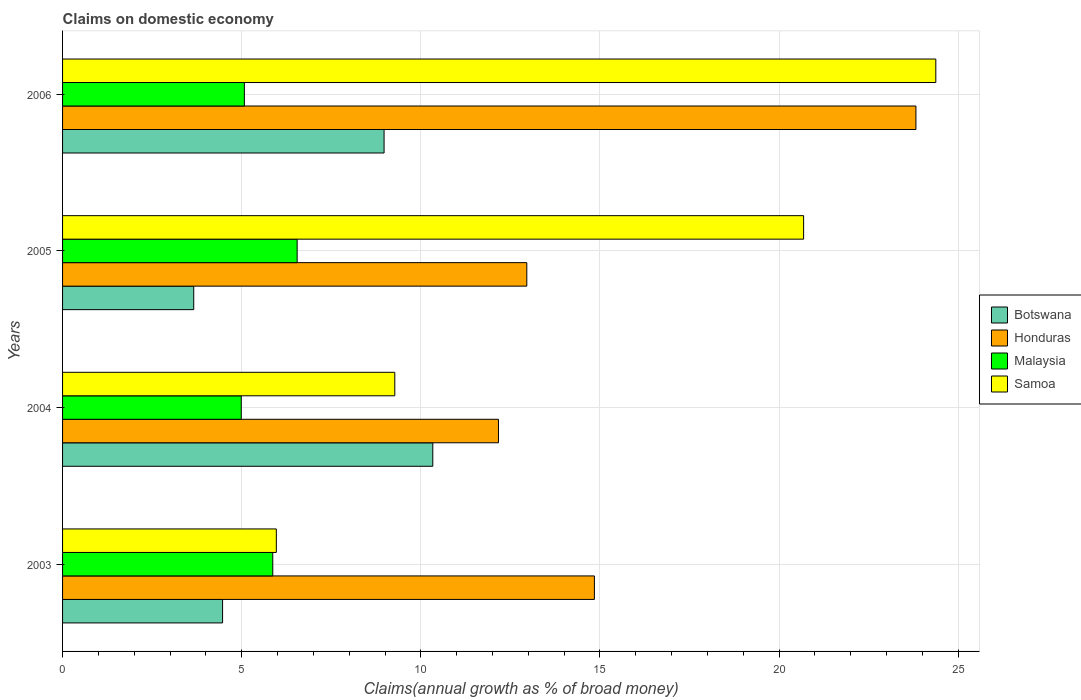How many different coloured bars are there?
Your answer should be compact. 4. How many groups of bars are there?
Keep it short and to the point. 4. Are the number of bars on each tick of the Y-axis equal?
Offer a very short reply. Yes. How many bars are there on the 3rd tick from the top?
Offer a terse response. 4. What is the label of the 2nd group of bars from the top?
Your answer should be very brief. 2005. What is the percentage of broad money claimed on domestic economy in Samoa in 2005?
Ensure brevity in your answer.  20.68. Across all years, what is the maximum percentage of broad money claimed on domestic economy in Botswana?
Provide a succinct answer. 10.33. Across all years, what is the minimum percentage of broad money claimed on domestic economy in Malaysia?
Your answer should be compact. 4.99. In which year was the percentage of broad money claimed on domestic economy in Honduras maximum?
Offer a very short reply. 2006. What is the total percentage of broad money claimed on domestic economy in Botswana in the graph?
Provide a short and direct response. 27.44. What is the difference between the percentage of broad money claimed on domestic economy in Samoa in 2004 and that in 2006?
Offer a very short reply. -15.1. What is the difference between the percentage of broad money claimed on domestic economy in Honduras in 2006 and the percentage of broad money claimed on domestic economy in Samoa in 2003?
Ensure brevity in your answer.  17.85. What is the average percentage of broad money claimed on domestic economy in Samoa per year?
Your answer should be very brief. 15.08. In the year 2005, what is the difference between the percentage of broad money claimed on domestic economy in Botswana and percentage of broad money claimed on domestic economy in Samoa?
Your response must be concise. -17.02. What is the ratio of the percentage of broad money claimed on domestic economy in Botswana in 2004 to that in 2006?
Your answer should be very brief. 1.15. What is the difference between the highest and the second highest percentage of broad money claimed on domestic economy in Botswana?
Make the answer very short. 1.36. What is the difference between the highest and the lowest percentage of broad money claimed on domestic economy in Samoa?
Your response must be concise. 18.41. What does the 1st bar from the top in 2004 represents?
Your response must be concise. Samoa. What does the 2nd bar from the bottom in 2006 represents?
Keep it short and to the point. Honduras. How many years are there in the graph?
Keep it short and to the point. 4. Are the values on the major ticks of X-axis written in scientific E-notation?
Offer a very short reply. No. Does the graph contain any zero values?
Your response must be concise. No. Where does the legend appear in the graph?
Make the answer very short. Center right. How many legend labels are there?
Give a very brief answer. 4. What is the title of the graph?
Your answer should be very brief. Claims on domestic economy. What is the label or title of the X-axis?
Keep it short and to the point. Claims(annual growth as % of broad money). What is the Claims(annual growth as % of broad money) in Botswana in 2003?
Make the answer very short. 4.47. What is the Claims(annual growth as % of broad money) in Honduras in 2003?
Your answer should be compact. 14.84. What is the Claims(annual growth as % of broad money) in Malaysia in 2003?
Your answer should be very brief. 5.87. What is the Claims(annual growth as % of broad money) in Samoa in 2003?
Your answer should be compact. 5.97. What is the Claims(annual growth as % of broad money) of Botswana in 2004?
Offer a very short reply. 10.33. What is the Claims(annual growth as % of broad money) of Honduras in 2004?
Offer a very short reply. 12.17. What is the Claims(annual growth as % of broad money) in Malaysia in 2004?
Provide a succinct answer. 4.99. What is the Claims(annual growth as % of broad money) in Samoa in 2004?
Your answer should be compact. 9.27. What is the Claims(annual growth as % of broad money) of Botswana in 2005?
Give a very brief answer. 3.66. What is the Claims(annual growth as % of broad money) in Honduras in 2005?
Provide a succinct answer. 12.96. What is the Claims(annual growth as % of broad money) of Malaysia in 2005?
Your response must be concise. 6.55. What is the Claims(annual growth as % of broad money) in Samoa in 2005?
Provide a succinct answer. 20.68. What is the Claims(annual growth as % of broad money) in Botswana in 2006?
Keep it short and to the point. 8.97. What is the Claims(annual growth as % of broad money) in Honduras in 2006?
Your answer should be very brief. 23.82. What is the Claims(annual growth as % of broad money) of Malaysia in 2006?
Offer a terse response. 5.07. What is the Claims(annual growth as % of broad money) in Samoa in 2006?
Offer a very short reply. 24.37. Across all years, what is the maximum Claims(annual growth as % of broad money) in Botswana?
Keep it short and to the point. 10.33. Across all years, what is the maximum Claims(annual growth as % of broad money) in Honduras?
Provide a short and direct response. 23.82. Across all years, what is the maximum Claims(annual growth as % of broad money) in Malaysia?
Your answer should be very brief. 6.55. Across all years, what is the maximum Claims(annual growth as % of broad money) of Samoa?
Provide a succinct answer. 24.37. Across all years, what is the minimum Claims(annual growth as % of broad money) of Botswana?
Provide a short and direct response. 3.66. Across all years, what is the minimum Claims(annual growth as % of broad money) in Honduras?
Offer a terse response. 12.17. Across all years, what is the minimum Claims(annual growth as % of broad money) of Malaysia?
Your answer should be compact. 4.99. Across all years, what is the minimum Claims(annual growth as % of broad money) in Samoa?
Your answer should be compact. 5.97. What is the total Claims(annual growth as % of broad money) in Botswana in the graph?
Your response must be concise. 27.44. What is the total Claims(annual growth as % of broad money) of Honduras in the graph?
Offer a terse response. 63.79. What is the total Claims(annual growth as % of broad money) of Malaysia in the graph?
Offer a very short reply. 22.48. What is the total Claims(annual growth as % of broad money) in Samoa in the graph?
Provide a short and direct response. 60.3. What is the difference between the Claims(annual growth as % of broad money) in Botswana in 2003 and that in 2004?
Your answer should be compact. -5.87. What is the difference between the Claims(annual growth as % of broad money) of Honduras in 2003 and that in 2004?
Ensure brevity in your answer.  2.68. What is the difference between the Claims(annual growth as % of broad money) of Malaysia in 2003 and that in 2004?
Make the answer very short. 0.88. What is the difference between the Claims(annual growth as % of broad money) of Samoa in 2003 and that in 2004?
Your answer should be very brief. -3.31. What is the difference between the Claims(annual growth as % of broad money) of Botswana in 2003 and that in 2005?
Provide a short and direct response. 0.81. What is the difference between the Claims(annual growth as % of broad money) of Honduras in 2003 and that in 2005?
Give a very brief answer. 1.89. What is the difference between the Claims(annual growth as % of broad money) in Malaysia in 2003 and that in 2005?
Offer a terse response. -0.68. What is the difference between the Claims(annual growth as % of broad money) in Samoa in 2003 and that in 2005?
Offer a very short reply. -14.72. What is the difference between the Claims(annual growth as % of broad money) of Botswana in 2003 and that in 2006?
Keep it short and to the point. -4.51. What is the difference between the Claims(annual growth as % of broad money) in Honduras in 2003 and that in 2006?
Provide a short and direct response. -8.98. What is the difference between the Claims(annual growth as % of broad money) of Malaysia in 2003 and that in 2006?
Ensure brevity in your answer.  0.79. What is the difference between the Claims(annual growth as % of broad money) in Samoa in 2003 and that in 2006?
Provide a short and direct response. -18.41. What is the difference between the Claims(annual growth as % of broad money) of Botswana in 2004 and that in 2005?
Keep it short and to the point. 6.67. What is the difference between the Claims(annual growth as % of broad money) of Honduras in 2004 and that in 2005?
Provide a succinct answer. -0.79. What is the difference between the Claims(annual growth as % of broad money) of Malaysia in 2004 and that in 2005?
Your response must be concise. -1.56. What is the difference between the Claims(annual growth as % of broad money) of Samoa in 2004 and that in 2005?
Ensure brevity in your answer.  -11.41. What is the difference between the Claims(annual growth as % of broad money) in Botswana in 2004 and that in 2006?
Keep it short and to the point. 1.36. What is the difference between the Claims(annual growth as % of broad money) of Honduras in 2004 and that in 2006?
Keep it short and to the point. -11.65. What is the difference between the Claims(annual growth as % of broad money) in Malaysia in 2004 and that in 2006?
Your answer should be very brief. -0.09. What is the difference between the Claims(annual growth as % of broad money) of Samoa in 2004 and that in 2006?
Keep it short and to the point. -15.1. What is the difference between the Claims(annual growth as % of broad money) of Botswana in 2005 and that in 2006?
Ensure brevity in your answer.  -5.31. What is the difference between the Claims(annual growth as % of broad money) of Honduras in 2005 and that in 2006?
Offer a terse response. -10.86. What is the difference between the Claims(annual growth as % of broad money) in Malaysia in 2005 and that in 2006?
Your answer should be compact. 1.47. What is the difference between the Claims(annual growth as % of broad money) of Samoa in 2005 and that in 2006?
Your answer should be very brief. -3.69. What is the difference between the Claims(annual growth as % of broad money) in Botswana in 2003 and the Claims(annual growth as % of broad money) in Honduras in 2004?
Give a very brief answer. -7.7. What is the difference between the Claims(annual growth as % of broad money) in Botswana in 2003 and the Claims(annual growth as % of broad money) in Malaysia in 2004?
Offer a very short reply. -0.52. What is the difference between the Claims(annual growth as % of broad money) in Botswana in 2003 and the Claims(annual growth as % of broad money) in Samoa in 2004?
Ensure brevity in your answer.  -4.81. What is the difference between the Claims(annual growth as % of broad money) in Honduras in 2003 and the Claims(annual growth as % of broad money) in Malaysia in 2004?
Make the answer very short. 9.86. What is the difference between the Claims(annual growth as % of broad money) in Honduras in 2003 and the Claims(annual growth as % of broad money) in Samoa in 2004?
Make the answer very short. 5.57. What is the difference between the Claims(annual growth as % of broad money) in Malaysia in 2003 and the Claims(annual growth as % of broad money) in Samoa in 2004?
Give a very brief answer. -3.41. What is the difference between the Claims(annual growth as % of broad money) of Botswana in 2003 and the Claims(annual growth as % of broad money) of Honduras in 2005?
Offer a terse response. -8.49. What is the difference between the Claims(annual growth as % of broad money) in Botswana in 2003 and the Claims(annual growth as % of broad money) in Malaysia in 2005?
Ensure brevity in your answer.  -2.08. What is the difference between the Claims(annual growth as % of broad money) of Botswana in 2003 and the Claims(annual growth as % of broad money) of Samoa in 2005?
Give a very brief answer. -16.22. What is the difference between the Claims(annual growth as % of broad money) in Honduras in 2003 and the Claims(annual growth as % of broad money) in Malaysia in 2005?
Give a very brief answer. 8.3. What is the difference between the Claims(annual growth as % of broad money) in Honduras in 2003 and the Claims(annual growth as % of broad money) in Samoa in 2005?
Provide a short and direct response. -5.84. What is the difference between the Claims(annual growth as % of broad money) in Malaysia in 2003 and the Claims(annual growth as % of broad money) in Samoa in 2005?
Offer a terse response. -14.82. What is the difference between the Claims(annual growth as % of broad money) in Botswana in 2003 and the Claims(annual growth as % of broad money) in Honduras in 2006?
Your answer should be very brief. -19.35. What is the difference between the Claims(annual growth as % of broad money) in Botswana in 2003 and the Claims(annual growth as % of broad money) in Malaysia in 2006?
Your response must be concise. -0.61. What is the difference between the Claims(annual growth as % of broad money) of Botswana in 2003 and the Claims(annual growth as % of broad money) of Samoa in 2006?
Provide a succinct answer. -19.91. What is the difference between the Claims(annual growth as % of broad money) in Honduras in 2003 and the Claims(annual growth as % of broad money) in Malaysia in 2006?
Give a very brief answer. 9.77. What is the difference between the Claims(annual growth as % of broad money) in Honduras in 2003 and the Claims(annual growth as % of broad money) in Samoa in 2006?
Ensure brevity in your answer.  -9.53. What is the difference between the Claims(annual growth as % of broad money) of Malaysia in 2003 and the Claims(annual growth as % of broad money) of Samoa in 2006?
Your answer should be very brief. -18.51. What is the difference between the Claims(annual growth as % of broad money) of Botswana in 2004 and the Claims(annual growth as % of broad money) of Honduras in 2005?
Offer a very short reply. -2.62. What is the difference between the Claims(annual growth as % of broad money) in Botswana in 2004 and the Claims(annual growth as % of broad money) in Malaysia in 2005?
Provide a succinct answer. 3.79. What is the difference between the Claims(annual growth as % of broad money) in Botswana in 2004 and the Claims(annual growth as % of broad money) in Samoa in 2005?
Keep it short and to the point. -10.35. What is the difference between the Claims(annual growth as % of broad money) in Honduras in 2004 and the Claims(annual growth as % of broad money) in Malaysia in 2005?
Offer a very short reply. 5.62. What is the difference between the Claims(annual growth as % of broad money) of Honduras in 2004 and the Claims(annual growth as % of broad money) of Samoa in 2005?
Give a very brief answer. -8.52. What is the difference between the Claims(annual growth as % of broad money) of Malaysia in 2004 and the Claims(annual growth as % of broad money) of Samoa in 2005?
Offer a very short reply. -15.7. What is the difference between the Claims(annual growth as % of broad money) of Botswana in 2004 and the Claims(annual growth as % of broad money) of Honduras in 2006?
Provide a short and direct response. -13.49. What is the difference between the Claims(annual growth as % of broad money) of Botswana in 2004 and the Claims(annual growth as % of broad money) of Malaysia in 2006?
Provide a succinct answer. 5.26. What is the difference between the Claims(annual growth as % of broad money) of Botswana in 2004 and the Claims(annual growth as % of broad money) of Samoa in 2006?
Provide a short and direct response. -14.04. What is the difference between the Claims(annual growth as % of broad money) of Honduras in 2004 and the Claims(annual growth as % of broad money) of Malaysia in 2006?
Your response must be concise. 7.09. What is the difference between the Claims(annual growth as % of broad money) of Honduras in 2004 and the Claims(annual growth as % of broad money) of Samoa in 2006?
Ensure brevity in your answer.  -12.21. What is the difference between the Claims(annual growth as % of broad money) in Malaysia in 2004 and the Claims(annual growth as % of broad money) in Samoa in 2006?
Keep it short and to the point. -19.39. What is the difference between the Claims(annual growth as % of broad money) in Botswana in 2005 and the Claims(annual growth as % of broad money) in Honduras in 2006?
Your answer should be very brief. -20.16. What is the difference between the Claims(annual growth as % of broad money) of Botswana in 2005 and the Claims(annual growth as % of broad money) of Malaysia in 2006?
Give a very brief answer. -1.41. What is the difference between the Claims(annual growth as % of broad money) in Botswana in 2005 and the Claims(annual growth as % of broad money) in Samoa in 2006?
Make the answer very short. -20.71. What is the difference between the Claims(annual growth as % of broad money) of Honduras in 2005 and the Claims(annual growth as % of broad money) of Malaysia in 2006?
Your answer should be very brief. 7.88. What is the difference between the Claims(annual growth as % of broad money) in Honduras in 2005 and the Claims(annual growth as % of broad money) in Samoa in 2006?
Provide a short and direct response. -11.42. What is the difference between the Claims(annual growth as % of broad money) in Malaysia in 2005 and the Claims(annual growth as % of broad money) in Samoa in 2006?
Provide a succinct answer. -17.83. What is the average Claims(annual growth as % of broad money) in Botswana per year?
Provide a succinct answer. 6.86. What is the average Claims(annual growth as % of broad money) in Honduras per year?
Offer a terse response. 15.95. What is the average Claims(annual growth as % of broad money) of Malaysia per year?
Your response must be concise. 5.62. What is the average Claims(annual growth as % of broad money) in Samoa per year?
Make the answer very short. 15.07. In the year 2003, what is the difference between the Claims(annual growth as % of broad money) in Botswana and Claims(annual growth as % of broad money) in Honduras?
Provide a short and direct response. -10.38. In the year 2003, what is the difference between the Claims(annual growth as % of broad money) in Botswana and Claims(annual growth as % of broad money) in Malaysia?
Provide a succinct answer. -1.4. In the year 2003, what is the difference between the Claims(annual growth as % of broad money) of Botswana and Claims(annual growth as % of broad money) of Samoa?
Your answer should be very brief. -1.5. In the year 2003, what is the difference between the Claims(annual growth as % of broad money) in Honduras and Claims(annual growth as % of broad money) in Malaysia?
Provide a succinct answer. 8.98. In the year 2003, what is the difference between the Claims(annual growth as % of broad money) in Honduras and Claims(annual growth as % of broad money) in Samoa?
Offer a very short reply. 8.88. In the year 2003, what is the difference between the Claims(annual growth as % of broad money) of Malaysia and Claims(annual growth as % of broad money) of Samoa?
Give a very brief answer. -0.1. In the year 2004, what is the difference between the Claims(annual growth as % of broad money) in Botswana and Claims(annual growth as % of broad money) in Honduras?
Your answer should be compact. -1.83. In the year 2004, what is the difference between the Claims(annual growth as % of broad money) of Botswana and Claims(annual growth as % of broad money) of Malaysia?
Give a very brief answer. 5.35. In the year 2004, what is the difference between the Claims(annual growth as % of broad money) in Botswana and Claims(annual growth as % of broad money) in Samoa?
Offer a very short reply. 1.06. In the year 2004, what is the difference between the Claims(annual growth as % of broad money) in Honduras and Claims(annual growth as % of broad money) in Malaysia?
Your response must be concise. 7.18. In the year 2004, what is the difference between the Claims(annual growth as % of broad money) of Honduras and Claims(annual growth as % of broad money) of Samoa?
Your answer should be very brief. 2.89. In the year 2004, what is the difference between the Claims(annual growth as % of broad money) of Malaysia and Claims(annual growth as % of broad money) of Samoa?
Give a very brief answer. -4.29. In the year 2005, what is the difference between the Claims(annual growth as % of broad money) in Botswana and Claims(annual growth as % of broad money) in Honduras?
Offer a terse response. -9.3. In the year 2005, what is the difference between the Claims(annual growth as % of broad money) in Botswana and Claims(annual growth as % of broad money) in Malaysia?
Your answer should be very brief. -2.89. In the year 2005, what is the difference between the Claims(annual growth as % of broad money) in Botswana and Claims(annual growth as % of broad money) in Samoa?
Your answer should be very brief. -17.02. In the year 2005, what is the difference between the Claims(annual growth as % of broad money) of Honduras and Claims(annual growth as % of broad money) of Malaysia?
Offer a very short reply. 6.41. In the year 2005, what is the difference between the Claims(annual growth as % of broad money) of Honduras and Claims(annual growth as % of broad money) of Samoa?
Your answer should be compact. -7.73. In the year 2005, what is the difference between the Claims(annual growth as % of broad money) of Malaysia and Claims(annual growth as % of broad money) of Samoa?
Your answer should be very brief. -14.14. In the year 2006, what is the difference between the Claims(annual growth as % of broad money) in Botswana and Claims(annual growth as % of broad money) in Honduras?
Make the answer very short. -14.85. In the year 2006, what is the difference between the Claims(annual growth as % of broad money) of Botswana and Claims(annual growth as % of broad money) of Malaysia?
Offer a terse response. 3.9. In the year 2006, what is the difference between the Claims(annual growth as % of broad money) in Botswana and Claims(annual growth as % of broad money) in Samoa?
Keep it short and to the point. -15.4. In the year 2006, what is the difference between the Claims(annual growth as % of broad money) in Honduras and Claims(annual growth as % of broad money) in Malaysia?
Your answer should be very brief. 18.75. In the year 2006, what is the difference between the Claims(annual growth as % of broad money) of Honduras and Claims(annual growth as % of broad money) of Samoa?
Offer a terse response. -0.56. In the year 2006, what is the difference between the Claims(annual growth as % of broad money) of Malaysia and Claims(annual growth as % of broad money) of Samoa?
Make the answer very short. -19.3. What is the ratio of the Claims(annual growth as % of broad money) of Botswana in 2003 to that in 2004?
Offer a terse response. 0.43. What is the ratio of the Claims(annual growth as % of broad money) of Honduras in 2003 to that in 2004?
Ensure brevity in your answer.  1.22. What is the ratio of the Claims(annual growth as % of broad money) of Malaysia in 2003 to that in 2004?
Offer a very short reply. 1.18. What is the ratio of the Claims(annual growth as % of broad money) of Samoa in 2003 to that in 2004?
Your answer should be very brief. 0.64. What is the ratio of the Claims(annual growth as % of broad money) in Botswana in 2003 to that in 2005?
Make the answer very short. 1.22. What is the ratio of the Claims(annual growth as % of broad money) in Honduras in 2003 to that in 2005?
Provide a succinct answer. 1.15. What is the ratio of the Claims(annual growth as % of broad money) of Malaysia in 2003 to that in 2005?
Offer a terse response. 0.9. What is the ratio of the Claims(annual growth as % of broad money) in Samoa in 2003 to that in 2005?
Your response must be concise. 0.29. What is the ratio of the Claims(annual growth as % of broad money) of Botswana in 2003 to that in 2006?
Make the answer very short. 0.5. What is the ratio of the Claims(annual growth as % of broad money) in Honduras in 2003 to that in 2006?
Keep it short and to the point. 0.62. What is the ratio of the Claims(annual growth as % of broad money) in Malaysia in 2003 to that in 2006?
Ensure brevity in your answer.  1.16. What is the ratio of the Claims(annual growth as % of broad money) of Samoa in 2003 to that in 2006?
Ensure brevity in your answer.  0.24. What is the ratio of the Claims(annual growth as % of broad money) of Botswana in 2004 to that in 2005?
Give a very brief answer. 2.82. What is the ratio of the Claims(annual growth as % of broad money) of Honduras in 2004 to that in 2005?
Your answer should be very brief. 0.94. What is the ratio of the Claims(annual growth as % of broad money) of Malaysia in 2004 to that in 2005?
Your answer should be very brief. 0.76. What is the ratio of the Claims(annual growth as % of broad money) in Samoa in 2004 to that in 2005?
Your response must be concise. 0.45. What is the ratio of the Claims(annual growth as % of broad money) of Botswana in 2004 to that in 2006?
Your answer should be compact. 1.15. What is the ratio of the Claims(annual growth as % of broad money) in Honduras in 2004 to that in 2006?
Provide a short and direct response. 0.51. What is the ratio of the Claims(annual growth as % of broad money) of Malaysia in 2004 to that in 2006?
Offer a very short reply. 0.98. What is the ratio of the Claims(annual growth as % of broad money) of Samoa in 2004 to that in 2006?
Keep it short and to the point. 0.38. What is the ratio of the Claims(annual growth as % of broad money) in Botswana in 2005 to that in 2006?
Provide a short and direct response. 0.41. What is the ratio of the Claims(annual growth as % of broad money) in Honduras in 2005 to that in 2006?
Keep it short and to the point. 0.54. What is the ratio of the Claims(annual growth as % of broad money) of Malaysia in 2005 to that in 2006?
Provide a succinct answer. 1.29. What is the ratio of the Claims(annual growth as % of broad money) of Samoa in 2005 to that in 2006?
Make the answer very short. 0.85. What is the difference between the highest and the second highest Claims(annual growth as % of broad money) of Botswana?
Your answer should be compact. 1.36. What is the difference between the highest and the second highest Claims(annual growth as % of broad money) of Honduras?
Give a very brief answer. 8.98. What is the difference between the highest and the second highest Claims(annual growth as % of broad money) of Malaysia?
Your answer should be very brief. 0.68. What is the difference between the highest and the second highest Claims(annual growth as % of broad money) in Samoa?
Your answer should be very brief. 3.69. What is the difference between the highest and the lowest Claims(annual growth as % of broad money) of Botswana?
Provide a short and direct response. 6.67. What is the difference between the highest and the lowest Claims(annual growth as % of broad money) in Honduras?
Your answer should be compact. 11.65. What is the difference between the highest and the lowest Claims(annual growth as % of broad money) in Malaysia?
Your answer should be compact. 1.56. What is the difference between the highest and the lowest Claims(annual growth as % of broad money) of Samoa?
Provide a short and direct response. 18.41. 